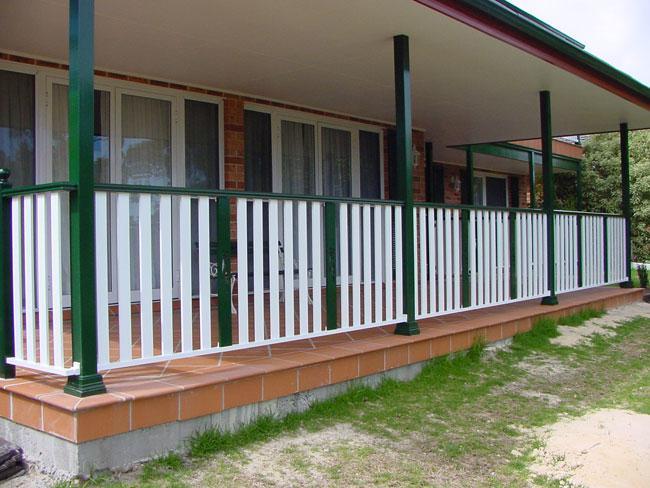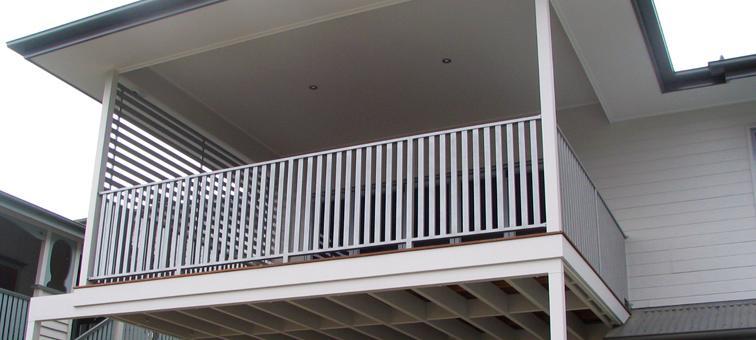The first image is the image on the left, the second image is the image on the right. Considering the images on both sides, is "There are are least three colored poles in between a white balcony fence." valid? Answer yes or no. Yes. The first image is the image on the left, the second image is the image on the right. For the images displayed, is the sentence "The balcony in the left image has close-together horizontal boards for rails, and the balcony on the right has vertical white bars for rails." factually correct? Answer yes or no. No. 